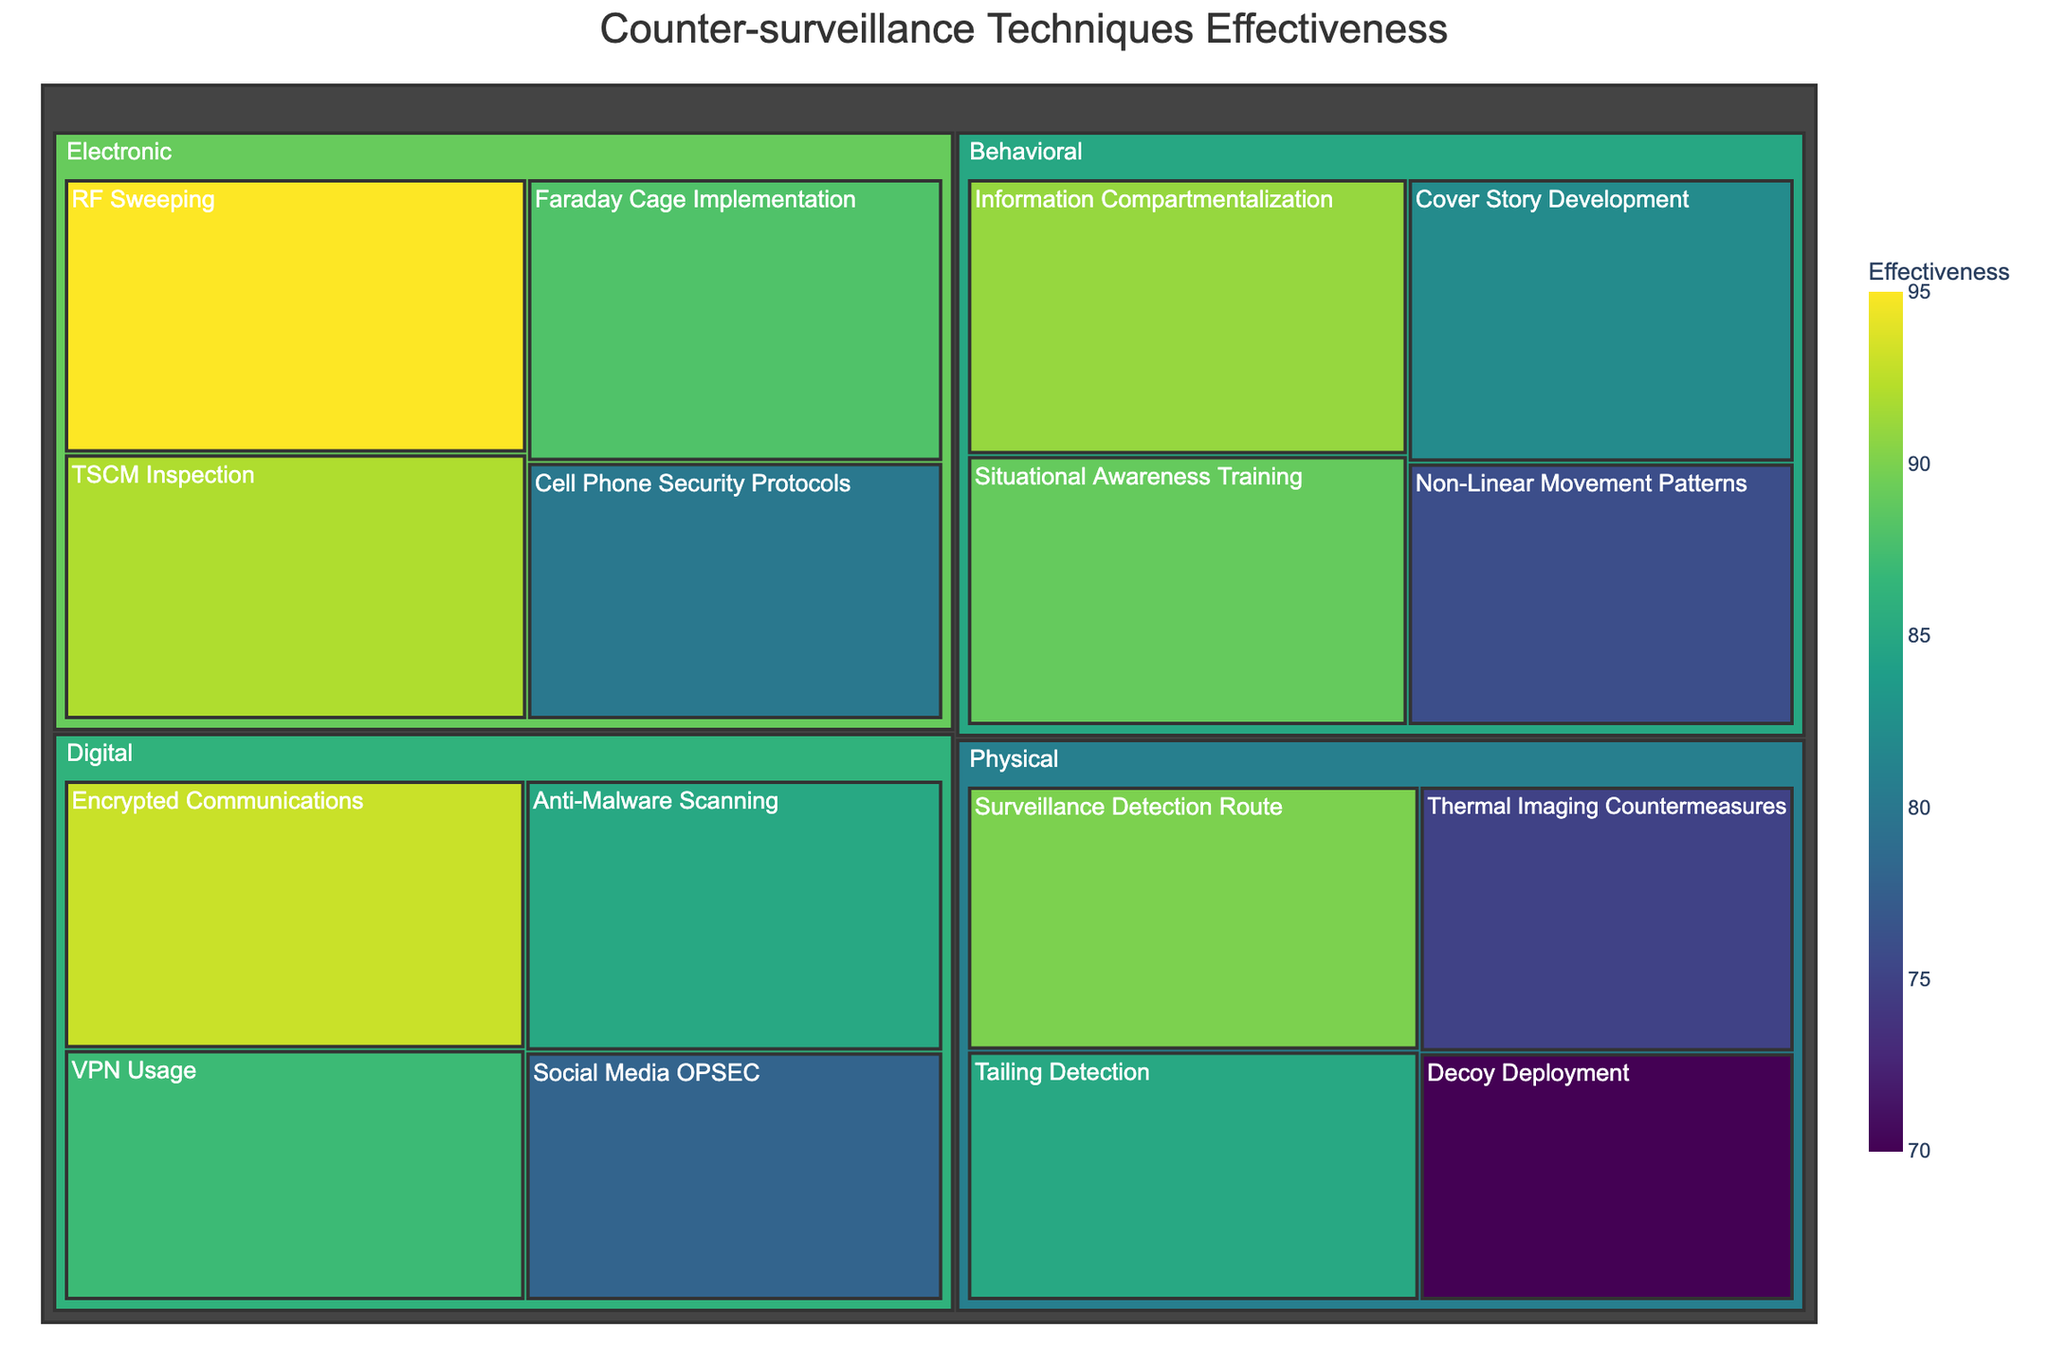what is the effectiveness of RF Sweeping? Locate "RF Sweeping" under the "Electronic" category and read its effectiveness value.
Answer: 95 Which category has the highest average effectiveness? Calculate the average effectiveness for each category: Physical (85+90+75+70)/4 = 80; Electronic (95+92+88+80)/4 = 88.75; Digital (93+85+87+78)/4 = 85.75; Behavioral (89+82+76+91)/4 = 84.5. The highest is "Electronic".
Answer: Electronic What is the application scenario for Thermal Imaging Countermeasures? Find "Thermal Imaging Countermeasures" in the "Physical" category and note its application scenario.
Answer: VIP Protection Which technique in the "Behavioral" category has the lowest effectiveness? Identify and compare the effectiveness values of all techniques in the "Behavioral" category: Situational Awareness Training (89), Cover Story Development (82), Non-Linear Movement Patterns (76), Information Compartmentalization (91). The lowest is "Non-Linear Movement Patterns".
Answer: Non-Linear Movement Patterns How many techniques have an effectiveness of 90 or above? Count the techniques with effectiveness values of 90 or above: Surveillance Detection Route (90), RF Sweeping (95), TSCM Inspection (92), Encrypted Communications (93), Information Compartmentalization (91). There are 5 techniques.
Answer: 5 Which category contains the technique used for high-risk travel? Cross-reference "High-Risk Travel" with its corresponding technique in the given data, which is "Decoy Deployment" under the "Physical" category.
Answer: Physical What is the effectiveness difference between TSCM Inspection and VPN Usage? Subtract the effectiveness of VPN Usage (87) from TSCM Inspection (92): 92 - 87 = 5.
Answer: 5 Which techniques fall under the "Secure Communication" scenario and what are their effectiveness values? Find techniques with "Secure Communication" in its application scenario and note their effectiveness: Faraday Cage Implementation (88).
Answer: Faraday Cage Implementation (88) 